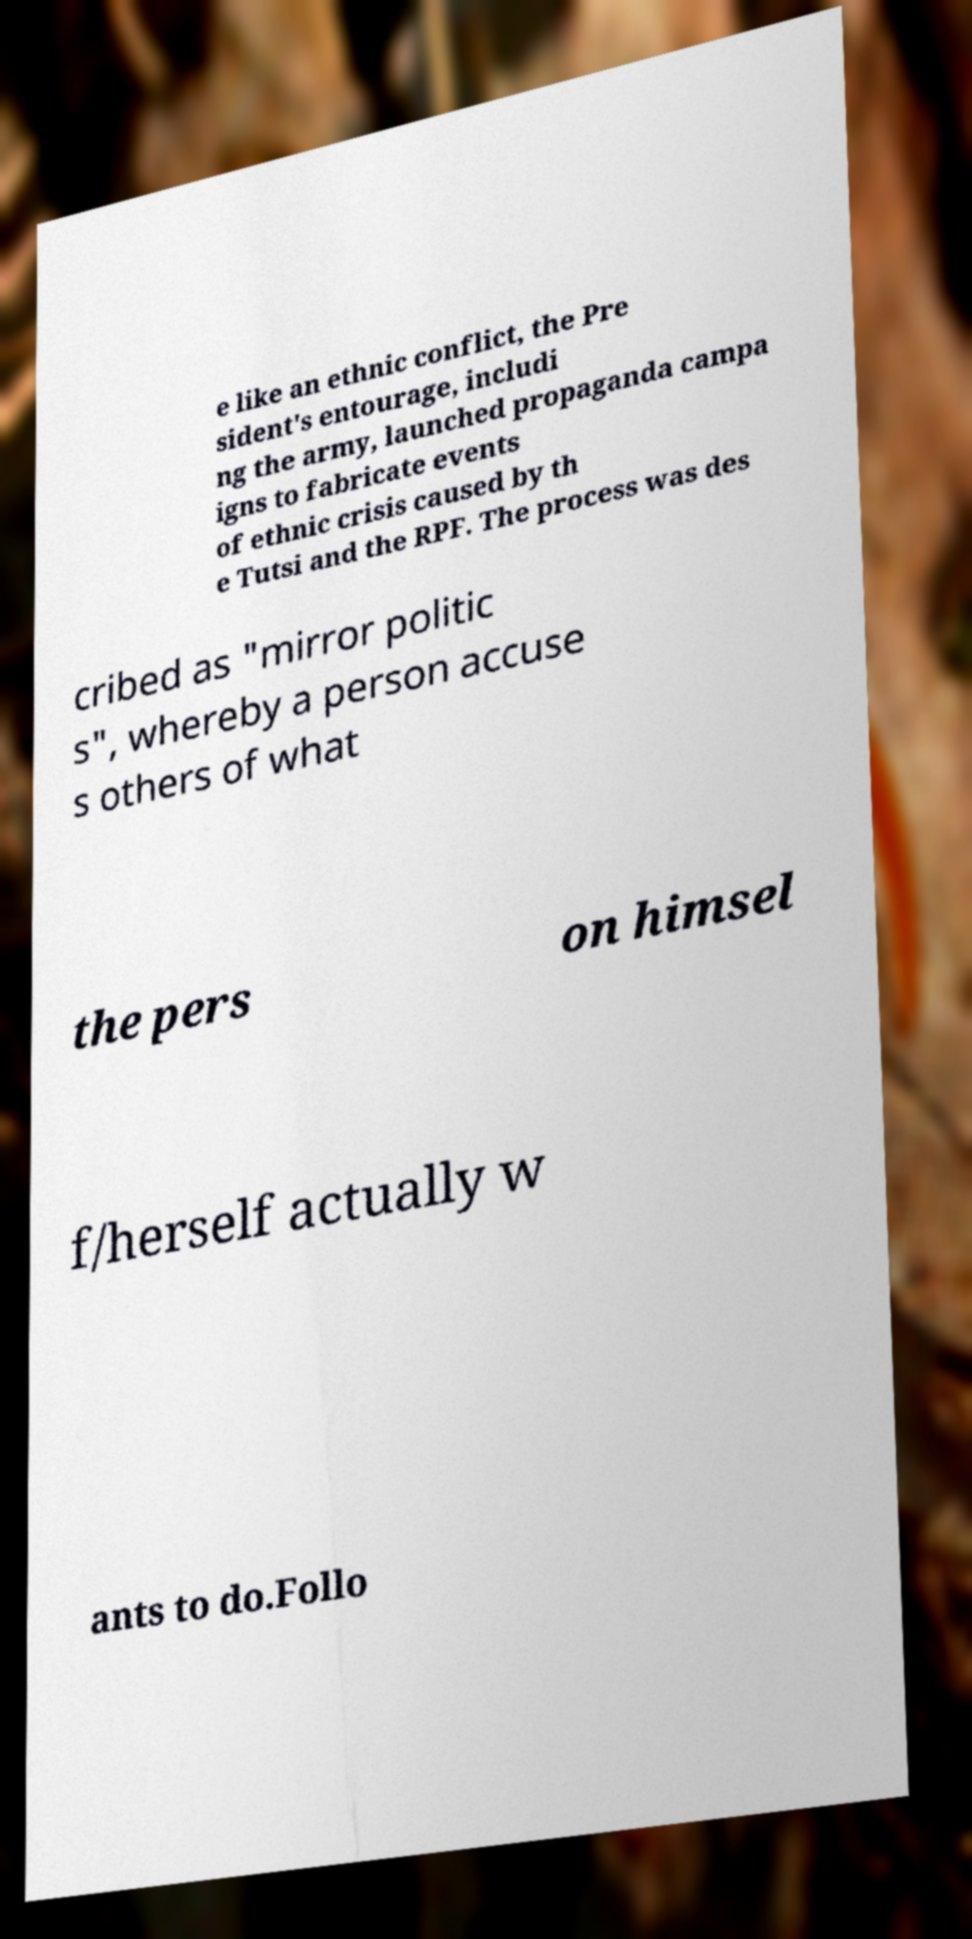Could you extract and type out the text from this image? e like an ethnic conflict, the Pre sident's entourage, includi ng the army, launched propaganda campa igns to fabricate events of ethnic crisis caused by th e Tutsi and the RPF. The process was des cribed as "mirror politic s", whereby a person accuse s others of what the pers on himsel f/herself actually w ants to do.Follo 